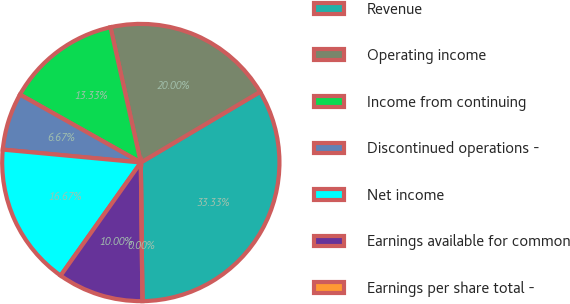Convert chart. <chart><loc_0><loc_0><loc_500><loc_500><pie_chart><fcel>Revenue<fcel>Operating income<fcel>Income from continuing<fcel>Discontinued operations -<fcel>Net income<fcel>Earnings available for common<fcel>Earnings per share total -<nl><fcel>33.33%<fcel>20.0%<fcel>13.33%<fcel>6.67%<fcel>16.67%<fcel>10.0%<fcel>0.0%<nl></chart> 